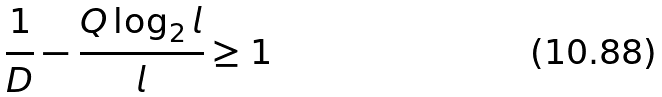<formula> <loc_0><loc_0><loc_500><loc_500>\frac { 1 } { D } - \frac { Q \log _ { 2 } l } { l } \geq 1</formula> 